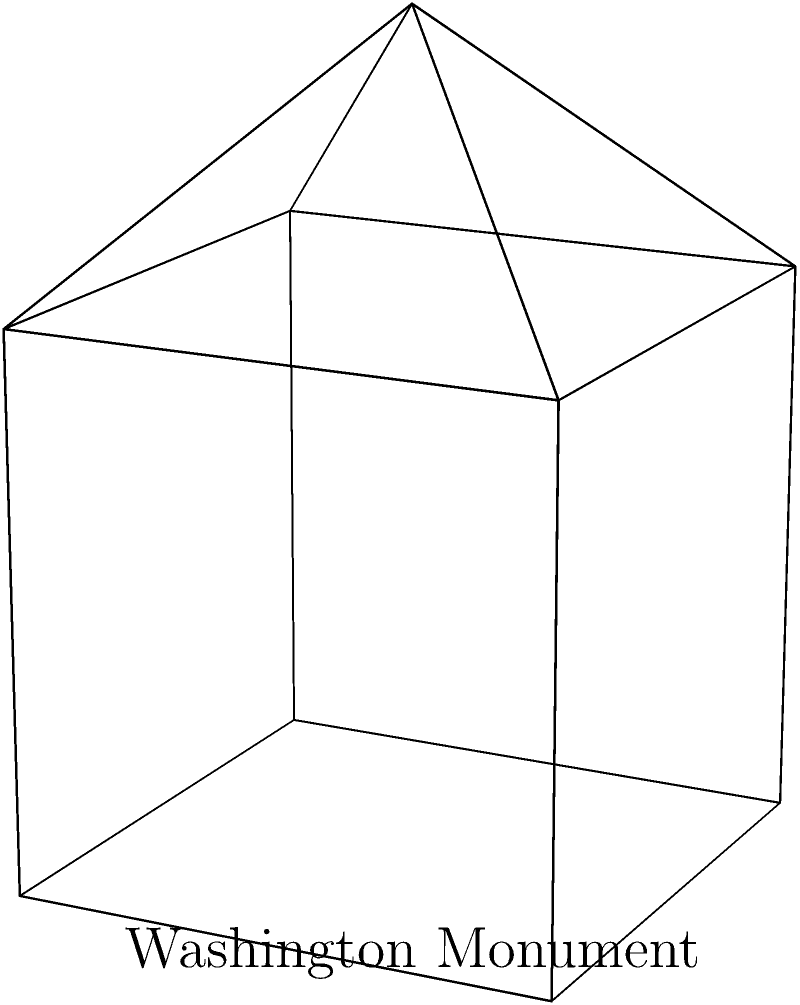Consider a simplified representation of the Washington Monument as shown in the figure: a cube with a pyramid on top. If we were to create a scale model of this structure using thin metal rods for edges and flat metal sheets for faces, how many rods (edges) would we need to maintain the structural integrity while preserving the Euler characteristic of a polyhedron? Assume the base of the pyramid coincides exactly with the top face of the cube. To solve this problem, we'll use the Euler characteristic formula and analyze the structure step-by-step:

1) Recall the Euler characteristic formula for convex polyhedra: $V - E + F = 2$, where $V$ is the number of vertices, $E$ is the number of edges, and $F$ is the number of faces.

2) Let's count the components of our structure:
   - The cube has 8 vertices
   - The pyramid adds 1 more vertex at the apex
   - Total vertices: $V = 9$

3) For the faces:
   - The cube has 6 faces
   - The pyramid adds 4 triangular faces
   - We remove 1 face where the pyramid meets the cube
   - Total faces: $F = 6 + 4 - 1 = 9$

4) Now we can use the Euler characteristic formula to find $E$:
   $9 - E + 9 = 2$
   $18 - E = 2$
   $E = 16$

5) To verify, let's count the edges:
   - The cube has 12 edges
   - The pyramid adds 4 edges from its apex to the cube's top vertices

Indeed, $12 + 4 = 16$ edges.

This representation maintains historical accuracy by simplifying the Washington Monument's structure while preserving its topological properties, aligning with a traditional interpretation of architectural history.
Answer: 16 edges 